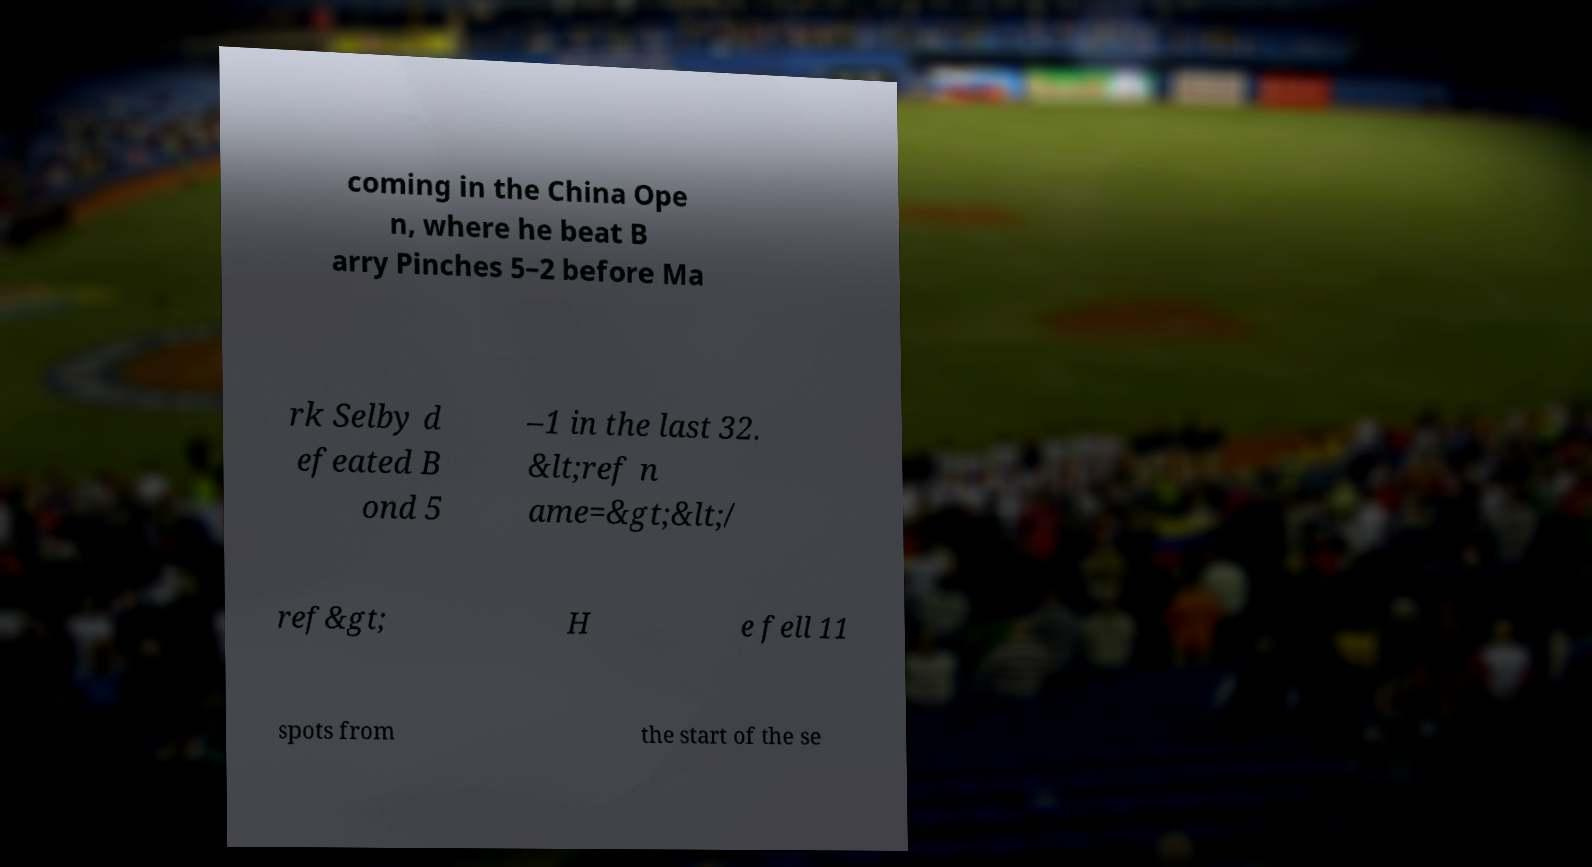Please identify and transcribe the text found in this image. coming in the China Ope n, where he beat B arry Pinches 5–2 before Ma rk Selby d efeated B ond 5 –1 in the last 32. &lt;ref n ame=&gt;&lt;/ ref&gt; H e fell 11 spots from the start of the se 